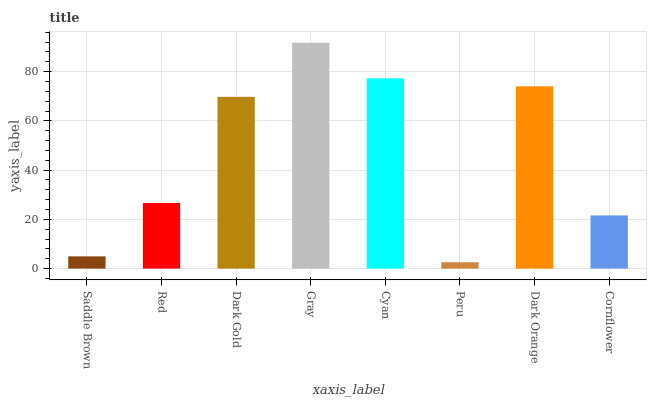Is Peru the minimum?
Answer yes or no. Yes. Is Gray the maximum?
Answer yes or no. Yes. Is Red the minimum?
Answer yes or no. No. Is Red the maximum?
Answer yes or no. No. Is Red greater than Saddle Brown?
Answer yes or no. Yes. Is Saddle Brown less than Red?
Answer yes or no. Yes. Is Saddle Brown greater than Red?
Answer yes or no. No. Is Red less than Saddle Brown?
Answer yes or no. No. Is Dark Gold the high median?
Answer yes or no. Yes. Is Red the low median?
Answer yes or no. Yes. Is Gray the high median?
Answer yes or no. No. Is Saddle Brown the low median?
Answer yes or no. No. 